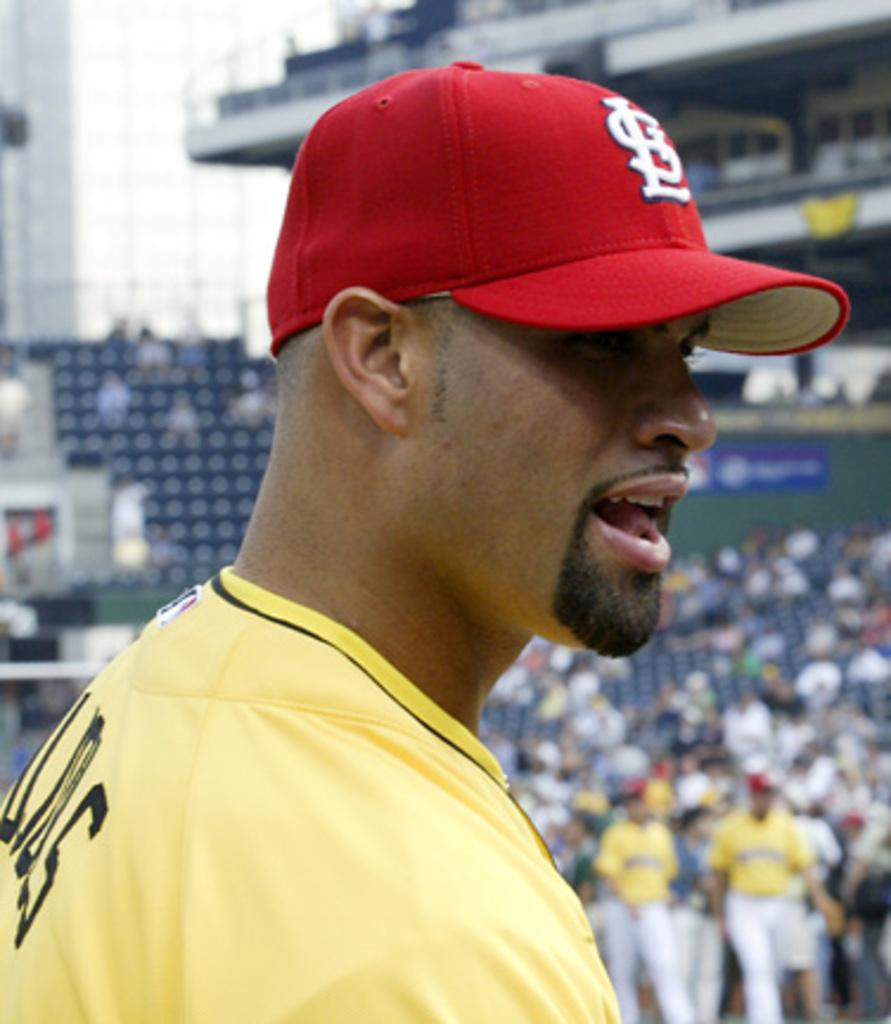<image>
Share a concise interpretation of the image provided. A baseball player is wearing a Saint Louis Cardinals hat.. 